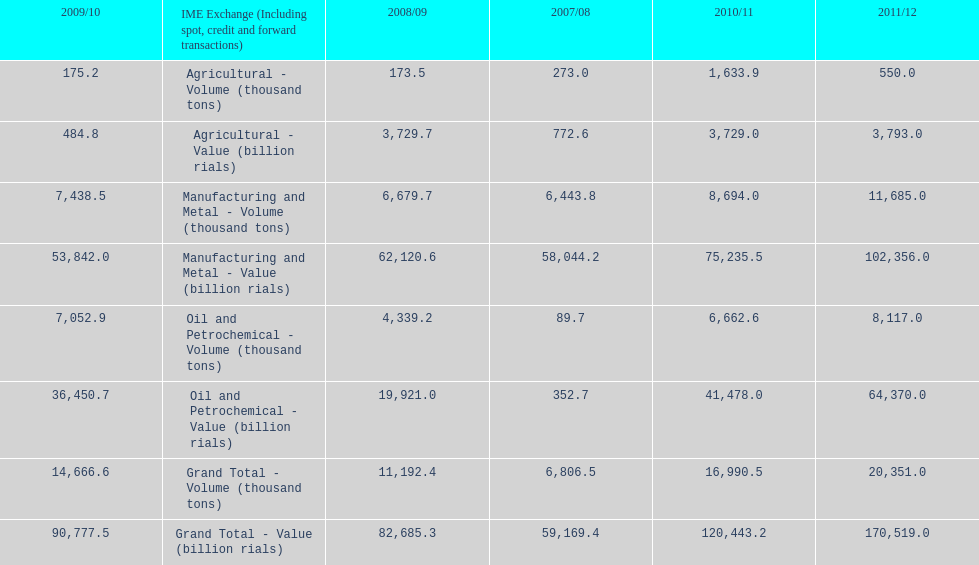Which year had the largest agricultural volume? 2010/11. 